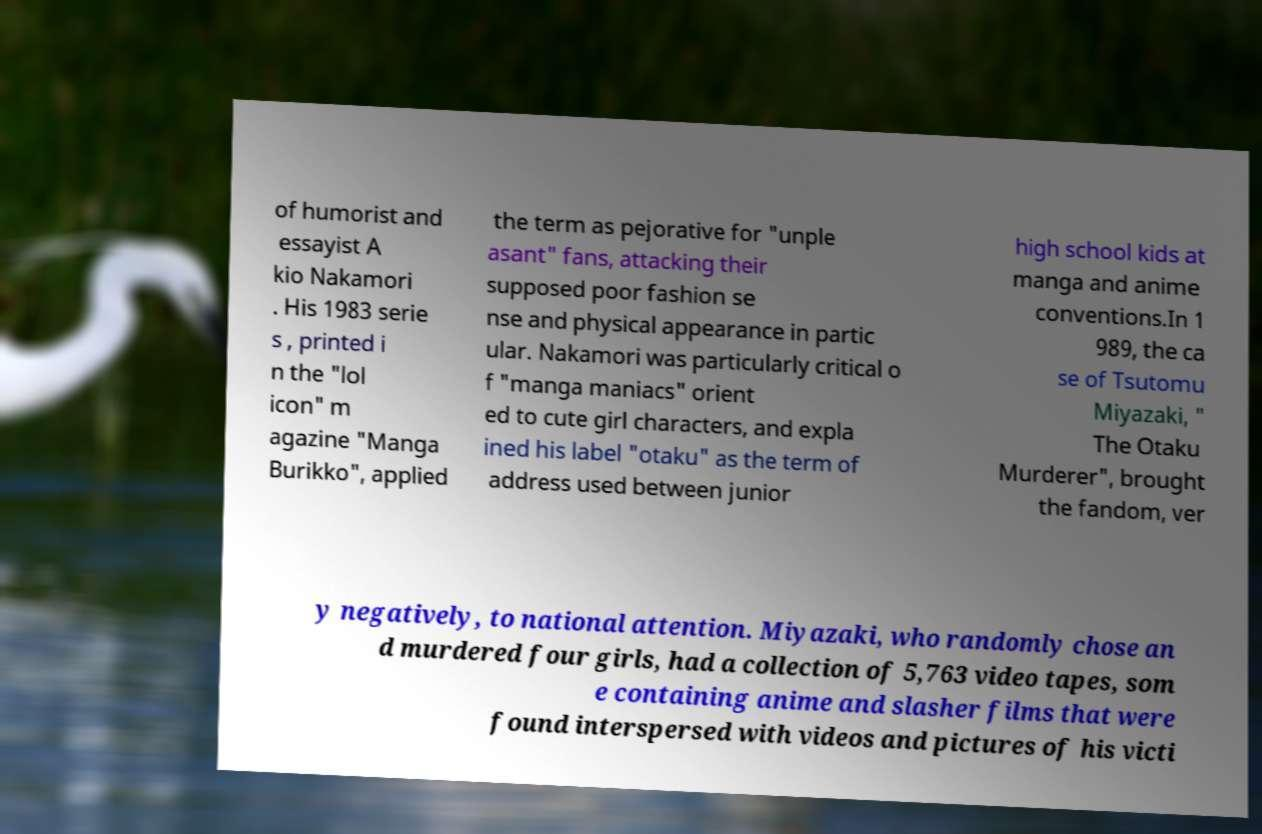For documentation purposes, I need the text within this image transcribed. Could you provide that? of humorist and essayist A kio Nakamori . His 1983 serie s , printed i n the "lol icon" m agazine "Manga Burikko", applied the term as pejorative for "unple asant" fans, attacking their supposed poor fashion se nse and physical appearance in partic ular. Nakamori was particularly critical o f "manga maniacs" orient ed to cute girl characters, and expla ined his label "otaku" as the term of address used between junior high school kids at manga and anime conventions.In 1 989, the ca se of Tsutomu Miyazaki, " The Otaku Murderer", brought the fandom, ver y negatively, to national attention. Miyazaki, who randomly chose an d murdered four girls, had a collection of 5,763 video tapes, som e containing anime and slasher films that were found interspersed with videos and pictures of his victi 